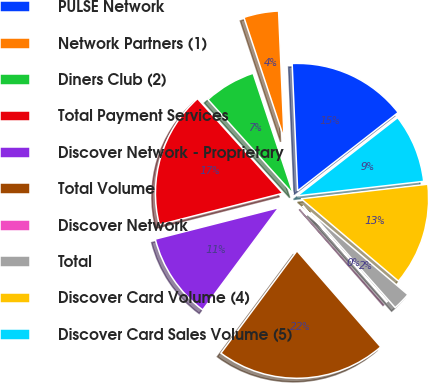Convert chart. <chart><loc_0><loc_0><loc_500><loc_500><pie_chart><fcel>PULSE Network<fcel>Network Partners (1)<fcel>Diners Club (2)<fcel>Total Payment Services<fcel>Discover Network - Proprietary<fcel>Total Volume<fcel>Discover Network<fcel>Total<fcel>Discover Card Volume (4)<fcel>Discover Card Sales Volume (5)<nl><fcel>15.15%<fcel>4.42%<fcel>6.57%<fcel>17.29%<fcel>10.86%<fcel>21.58%<fcel>0.13%<fcel>2.28%<fcel>13.0%<fcel>8.71%<nl></chart> 